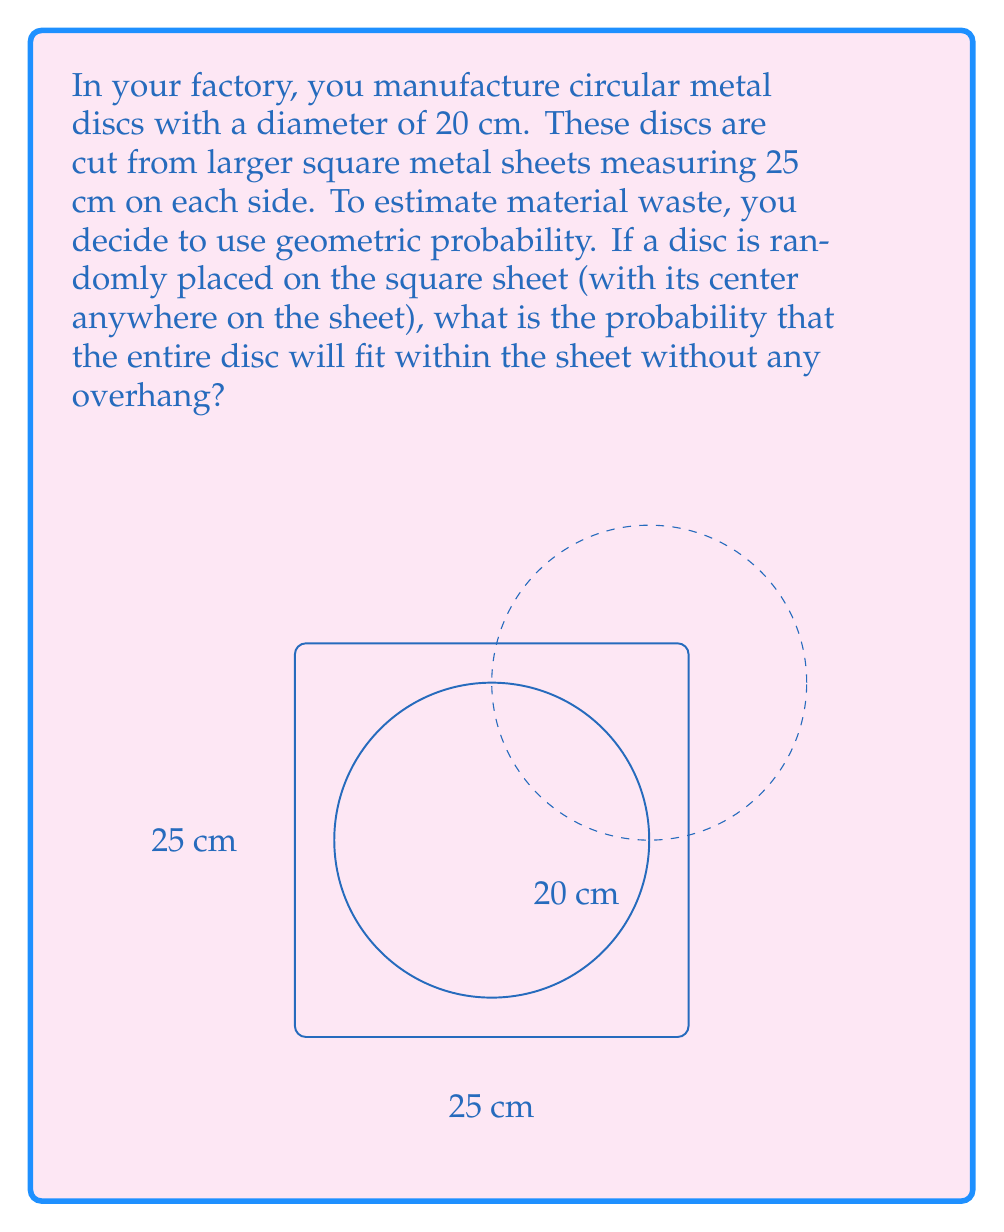Help me with this question. Let's approach this step-by-step:

1) For the disc to fit entirely within the square sheet, its center must be at least 10 cm (radius) away from all edges of the square.

2) This creates a smaller square within the original square where the center of the disc can be placed. Let's call the side length of this smaller square $x$.

3) The side length of the smaller square is:
   $x = 25 - 2(10) = 5$ cm

4) The area where the center of the disc can be placed to fit entirely within the sheet is:
   $A_{favorable} = x^2 = 5^2 = 25$ cm²

5) The total area where the center of the disc can be placed (anywhere on the sheet) is:
   $A_{total} = 25^2 = 625$ cm²

6) The probability is the ratio of the favorable area to the total area:

   $$P(\text{disc fits}) = \frac{A_{favorable}}{A_{total}} = \frac{25}{625} = \frac{1}{25} = 0.04$$

7) Therefore, the probability that a randomly placed disc will fit entirely within the sheet is 0.04 or 4%.
Answer: 0.04 